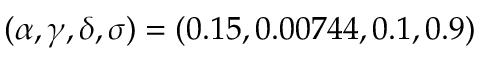<formula> <loc_0><loc_0><loc_500><loc_500>( \alpha , \gamma , \delta , \sigma ) = ( 0 . 1 5 , 0 . 0 0 7 4 4 , 0 . 1 , 0 . 9 )</formula> 